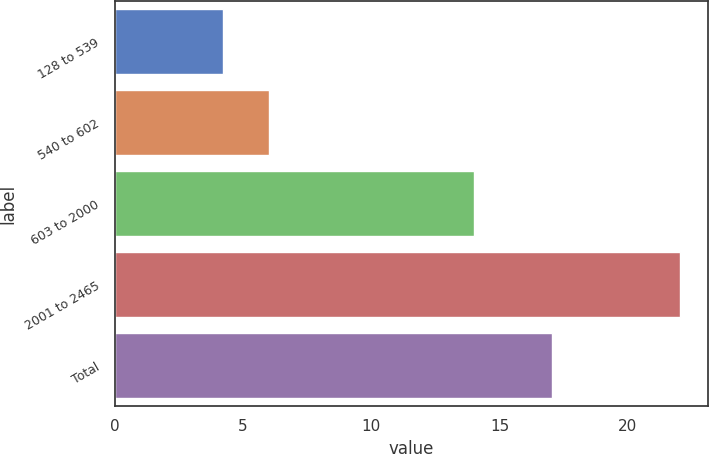Convert chart to OTSL. <chart><loc_0><loc_0><loc_500><loc_500><bar_chart><fcel>128 to 539<fcel>540 to 602<fcel>603 to 2000<fcel>2001 to 2465<fcel>Total<nl><fcel>4.21<fcel>5.99<fcel>14.01<fcel>22.03<fcel>17.03<nl></chart> 